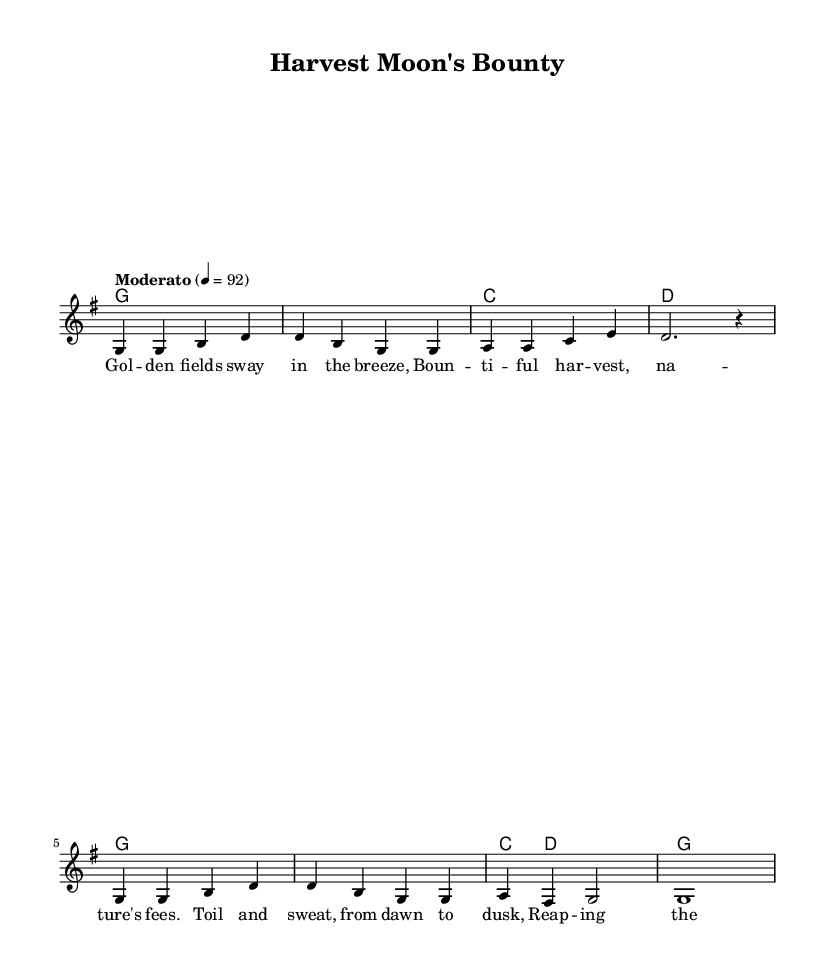What is the key signature of this music? The key signature shows a G major key, which has one sharp (F#). We can determine the key signature by looking for sharps or flats indicated at the beginning of the staff; in this case, there is one sharp, which identifies it as G major.
Answer: G major What is the time signature of this music? The time signature is found at the beginning of the score, indicated by the 4/4 notation. This indicates that there are four beats in each measure, and each beat is a quarter note.
Answer: 4/4 What tempo marking is present in the music? The tempo marking appears as "Moderato" with a metronome mark of 4 = 92. This indicates a moderate speed, and the number signifies the pulse of the music.
Answer: Moderato How many measures are in the melody? To find the number of measures, we can count the number of vertical bar lines in the melody section. Each segment of notes separated by these lines represents one measure. Counting the measures shows there are 8 total.
Answer: 8 What is the lyric of the first line? The first line of the lyrics states, "Gol -- den fields sway in the breeze," which is written above the respective melody notes in the score. This is a direct representation from the lyric mode section of the code.
Answer: Gol -- den fields sway in the breeze What is the last chord played in the harmony? The last chord in the harmony section is stated as "g1," which indicates that the final chord played is a G major chord, held for the duration specified in the score.
Answer: g What is the structure type of this song? The structure can be inferred from the presence of verses marked by lyrics and the accompanying melody and harmony; it fits the traditional folk ballad structure commonly found in songs about farming and harvest.
Answer: Folk ballad 